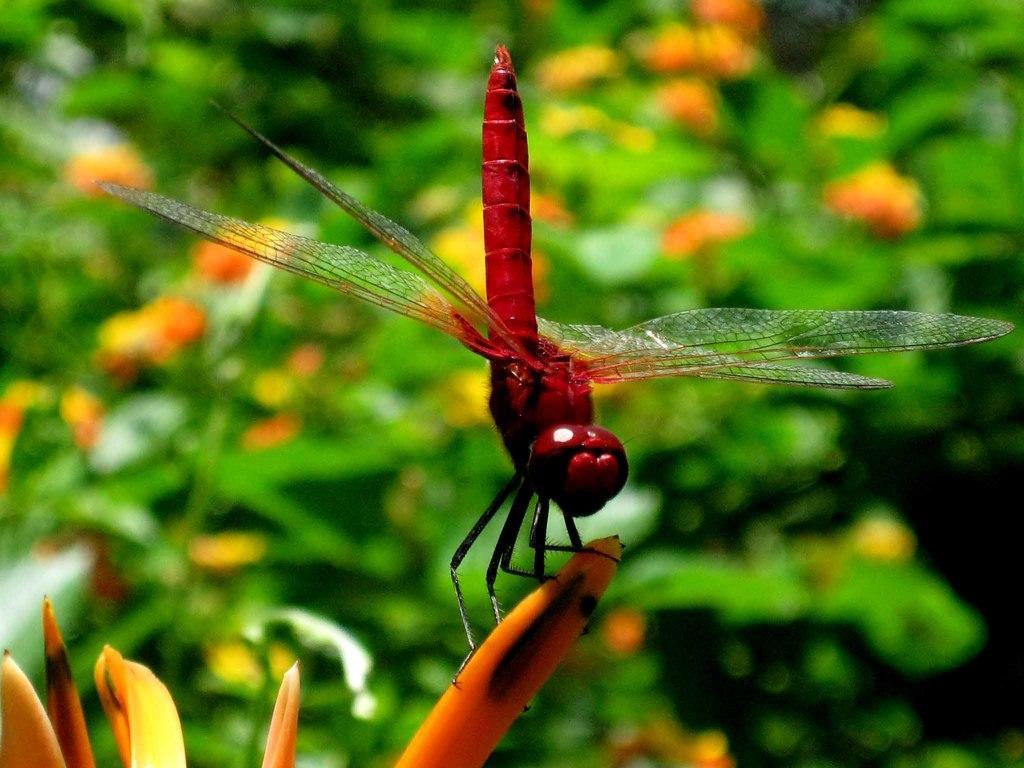Please provide a concise description of this image. Here there is an insect on a petal. In the background there are plants with flowers. 